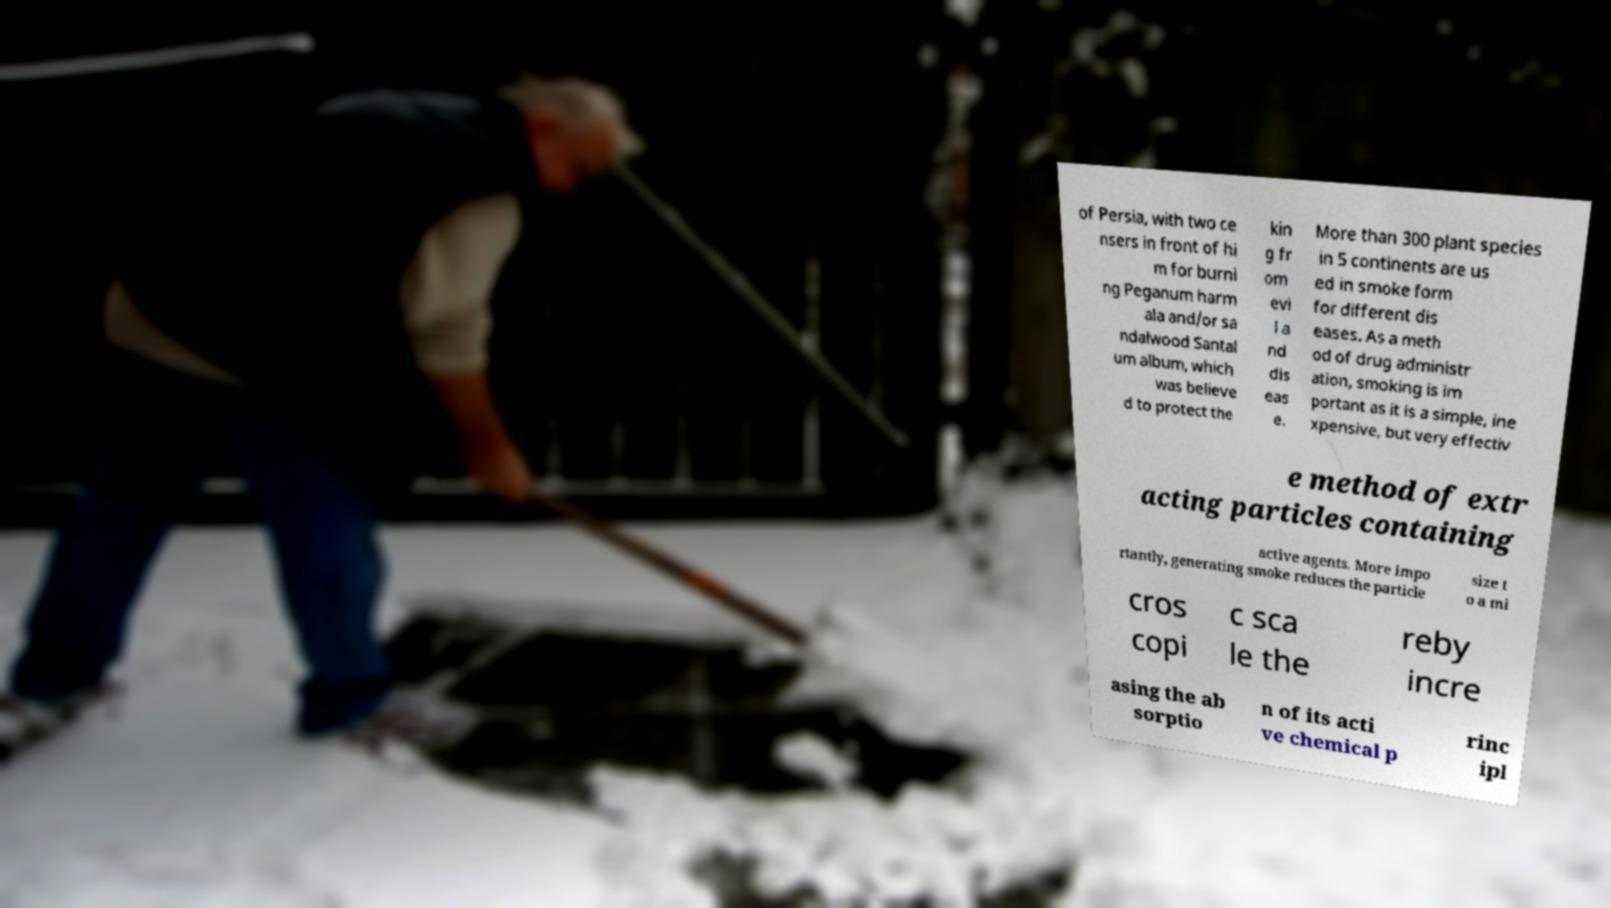What messages or text are displayed in this image? I need them in a readable, typed format. of Persia, with two ce nsers in front of hi m for burni ng Peganum harm ala and/or sa ndalwood Santal um album, which was believe d to protect the kin g fr om evi l a nd dis eas e. More than 300 plant species in 5 continents are us ed in smoke form for different dis eases. As a meth od of drug administr ation, smoking is im portant as it is a simple, ine xpensive, but very effectiv e method of extr acting particles containing active agents. More impo rtantly, generating smoke reduces the particle size t o a mi cros copi c sca le the reby incre asing the ab sorptio n of its acti ve chemical p rinc ipl 